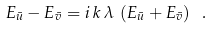Convert formula to latex. <formula><loc_0><loc_0><loc_500><loc_500>E _ { \bar { u } } - E _ { \bar { v } } = i \, k \, \lambda \, \left ( E _ { \bar { u } } + E _ { \bar { v } } \right ) \ .</formula> 